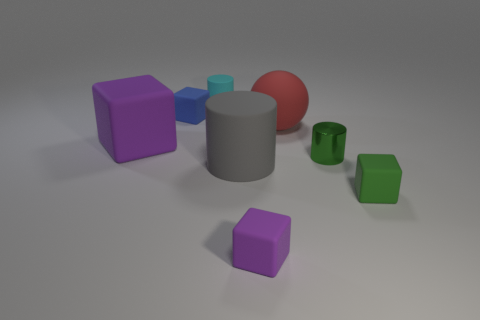Subtract all blue blocks. How many blocks are left? 3 Subtract 1 cylinders. How many cylinders are left? 2 Subtract all red cubes. Subtract all blue balls. How many cubes are left? 4 Add 2 gray objects. How many objects exist? 10 Subtract all cylinders. How many objects are left? 5 Subtract all big cylinders. Subtract all tiny green blocks. How many objects are left? 6 Add 6 tiny green rubber blocks. How many tiny green rubber blocks are left? 7 Add 6 small green objects. How many small green objects exist? 8 Subtract 0 green balls. How many objects are left? 8 